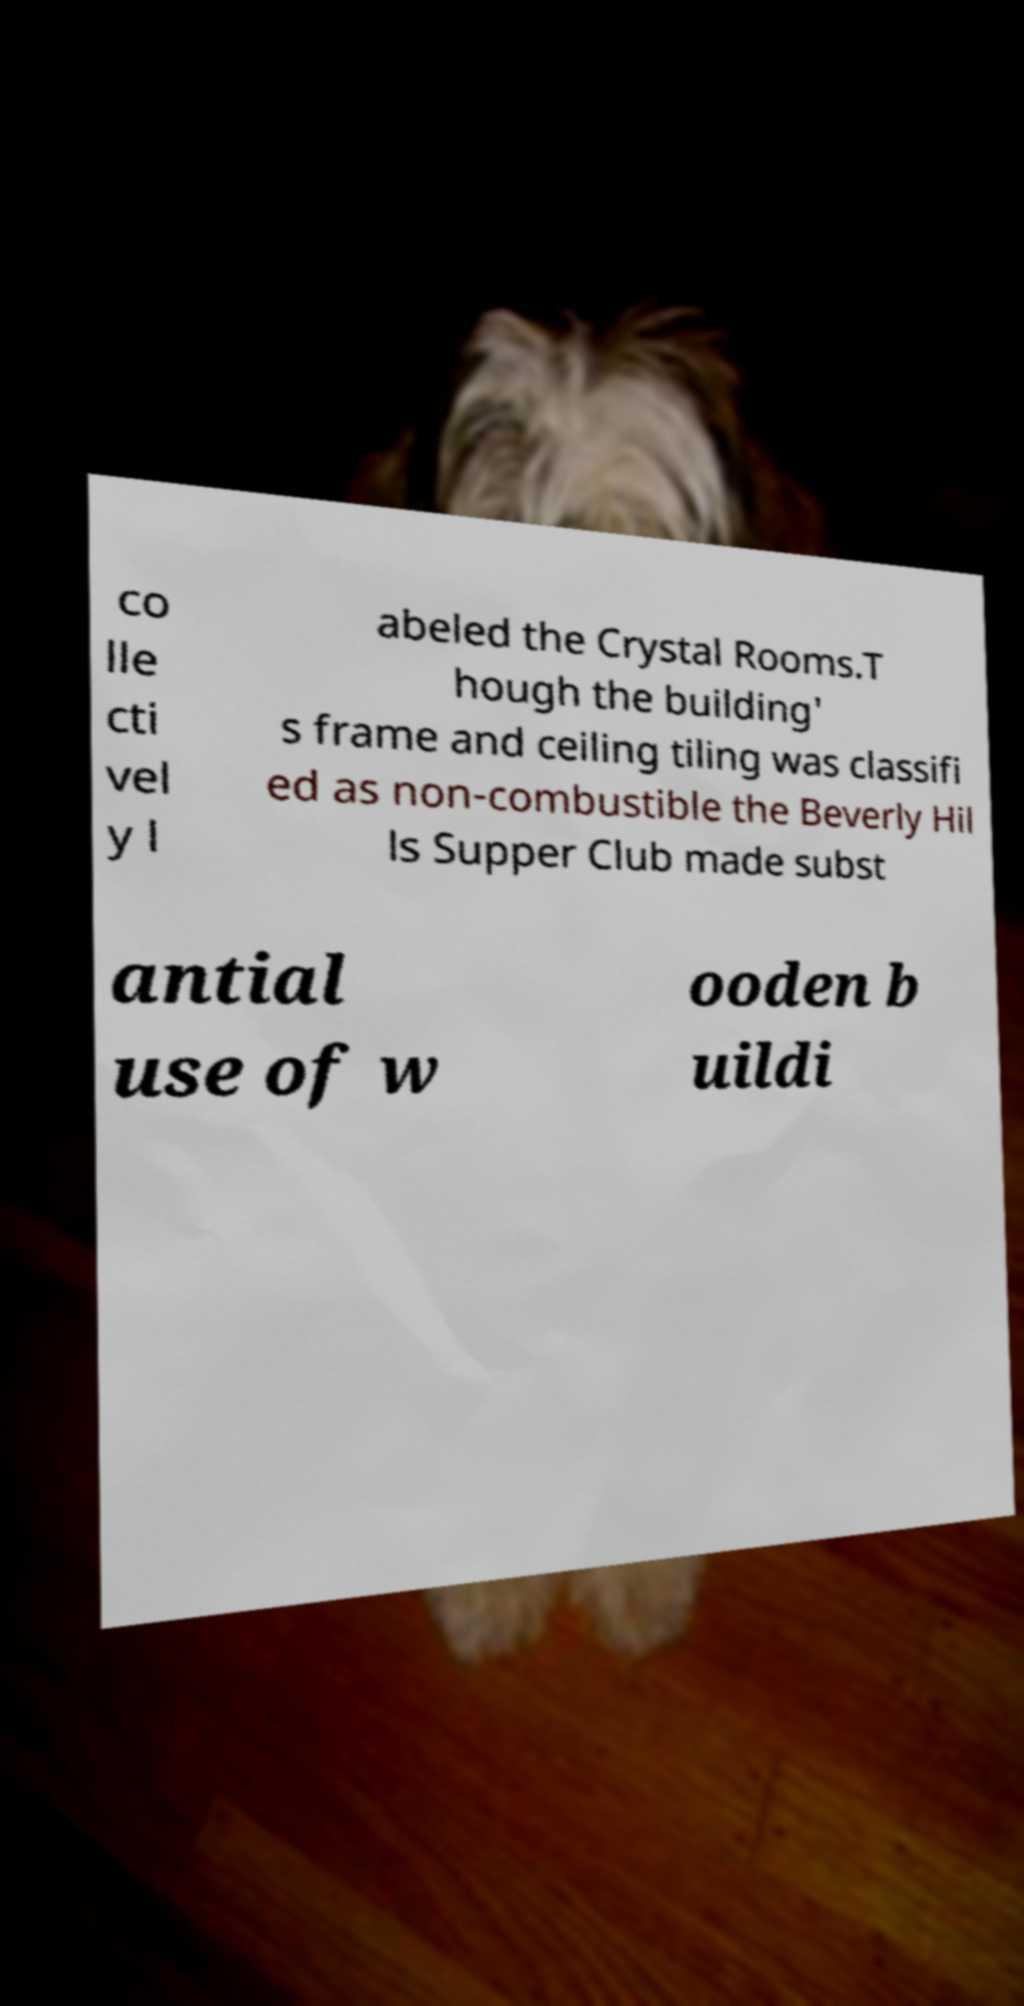Can you read and provide the text displayed in the image?This photo seems to have some interesting text. Can you extract and type it out for me? co lle cti vel y l abeled the Crystal Rooms.T hough the building' s frame and ceiling tiling was classifi ed as non-combustible the Beverly Hil ls Supper Club made subst antial use of w ooden b uildi 